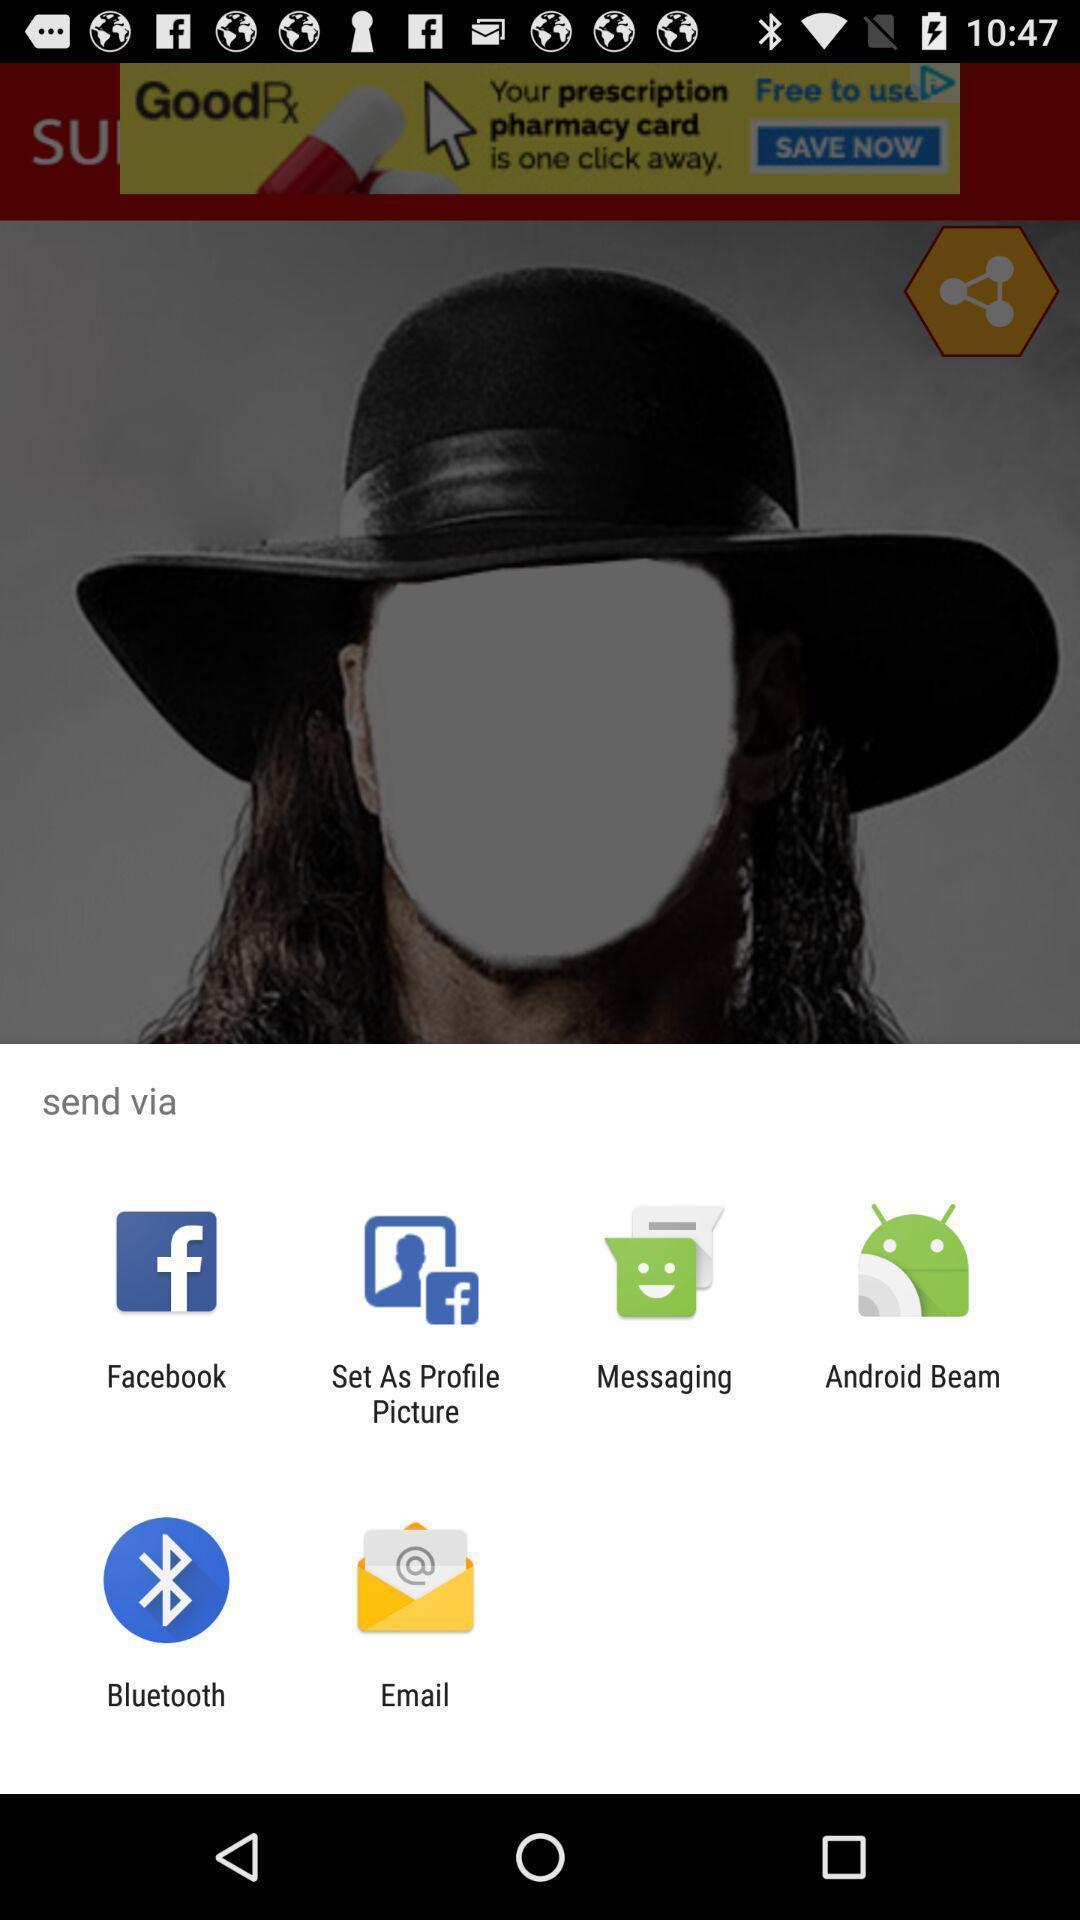Give me a summary of this screen capture. Pop-up with different options for sending a link. 